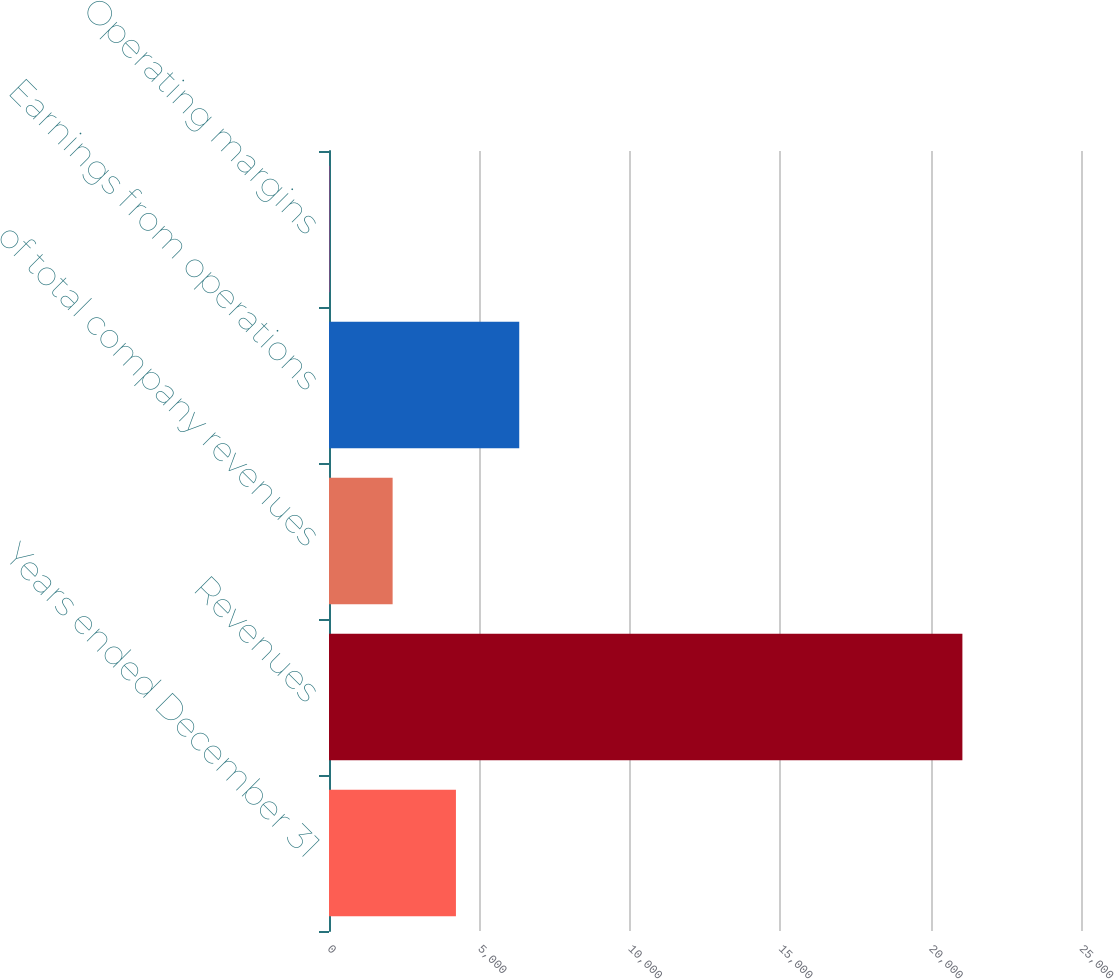<chart> <loc_0><loc_0><loc_500><loc_500><bar_chart><fcel>Years ended December 31<fcel>Revenues<fcel>of total company revenues<fcel>Earnings from operations<fcel>Operating margins<nl><fcel>4219.88<fcel>21057<fcel>2115.24<fcel>6324.52<fcel>10.6<nl></chart> 